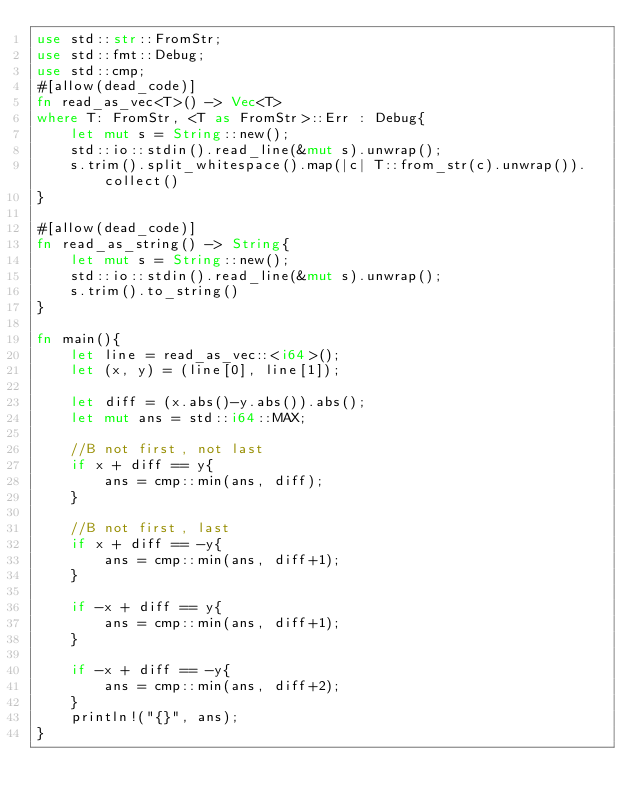<code> <loc_0><loc_0><loc_500><loc_500><_Rust_>use std::str::FromStr;
use std::fmt::Debug;
use std::cmp;
#[allow(dead_code)]
fn read_as_vec<T>() -> Vec<T>
where T: FromStr, <T as FromStr>::Err : Debug{
    let mut s = String::new();
    std::io::stdin().read_line(&mut s).unwrap();
    s.trim().split_whitespace().map(|c| T::from_str(c).unwrap()).collect()
}

#[allow(dead_code)]
fn read_as_string() -> String{
    let mut s = String::new();
    std::io::stdin().read_line(&mut s).unwrap();
    s.trim().to_string()
}

fn main(){
    let line = read_as_vec::<i64>();
    let (x, y) = (line[0], line[1]);

    let diff = (x.abs()-y.abs()).abs();
    let mut ans = std::i64::MAX;

    //B not first, not last
    if x + diff == y{
        ans = cmp::min(ans, diff);
    }

    //B not first, last
    if x + diff == -y{
        ans = cmp::min(ans, diff+1);
    }

    if -x + diff == y{
        ans = cmp::min(ans, diff+1);
    }

    if -x + diff == -y{
        ans = cmp::min(ans, diff+2);
    }
    println!("{}", ans);
}
</code> 